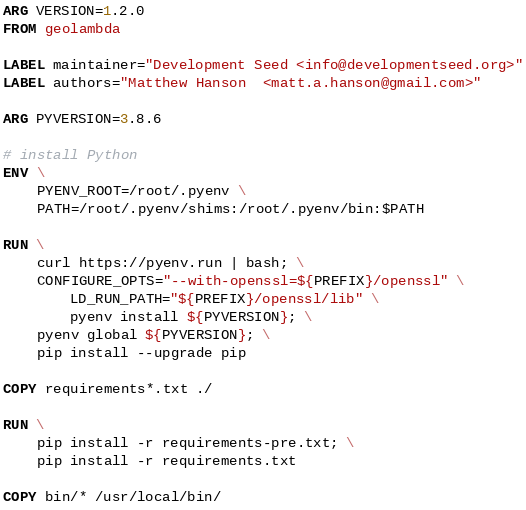Convert code to text. <code><loc_0><loc_0><loc_500><loc_500><_Dockerfile_>ARG VERSION=1.2.0
FROM geolambda

LABEL maintainer="Development Seed <info@developmentseed.org>"
LABEL authors="Matthew Hanson  <matt.a.hanson@gmail.com>"

ARG PYVERSION=3.8.6

# install Python
ENV \
    PYENV_ROOT=/root/.pyenv \
    PATH=/root/.pyenv/shims:/root/.pyenv/bin:$PATH

RUN \
    curl https://pyenv.run | bash; \
    CONFIGURE_OPTS="--with-openssl=${PREFIX}/openssl" \
        LD_RUN_PATH="${PREFIX}/openssl/lib" \
        pyenv install ${PYVERSION}; \
    pyenv global ${PYVERSION}; \
    pip install --upgrade pip

COPY requirements*.txt ./

RUN \
    pip install -r requirements-pre.txt; \
    pip install -r requirements.txt

COPY bin/* /usr/local/bin/
</code> 